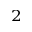Convert formula to latex. <formula><loc_0><loc_0><loc_500><loc_500>^ { 2 }</formula> 